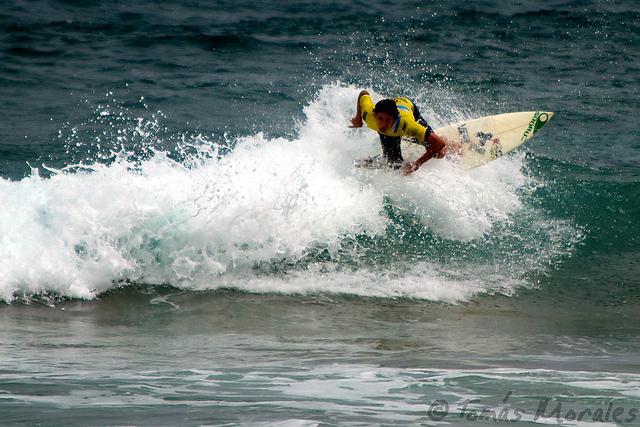Is the man on a boogie board?
Be succinct. No. What color is the surfboard on the wave?
Write a very short answer. White. Is this a lake or a ocean?
Be succinct. Ocean. What color is the surfboard?
Concise answer only. White. Is the surfer going to fall?
Be succinct. Yes. 